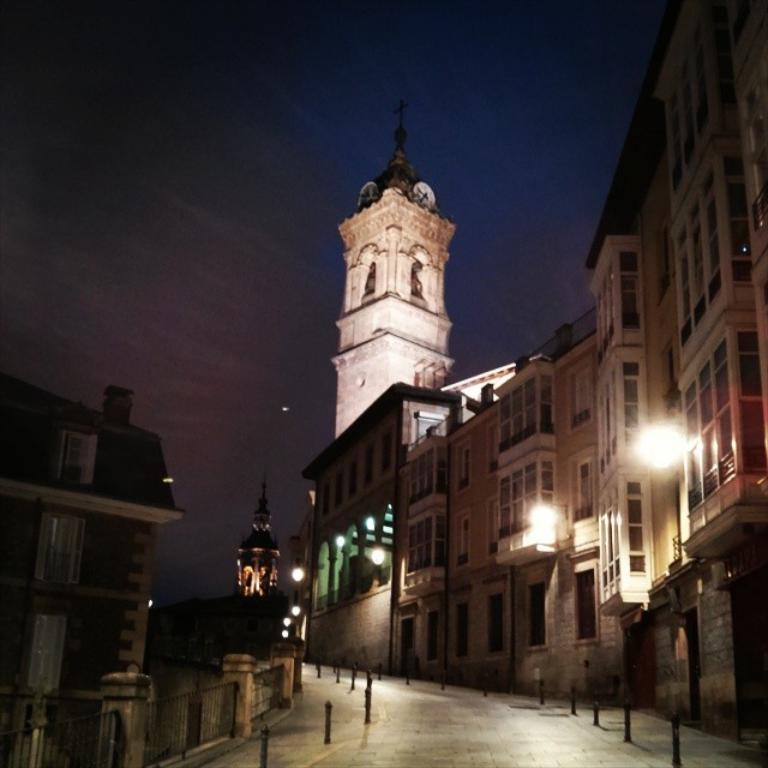Please provide a concise description of this image. In this picture we can see metal poles on the road and in the background we can see buildings, lights, sky. 